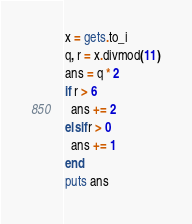Convert code to text. <code><loc_0><loc_0><loc_500><loc_500><_Ruby_>x = gets.to_i
q, r = x.divmod(11)
ans = q * 2
if r > 6
  ans += 2
elsif r > 0
  ans += 1
end
puts ans
</code> 